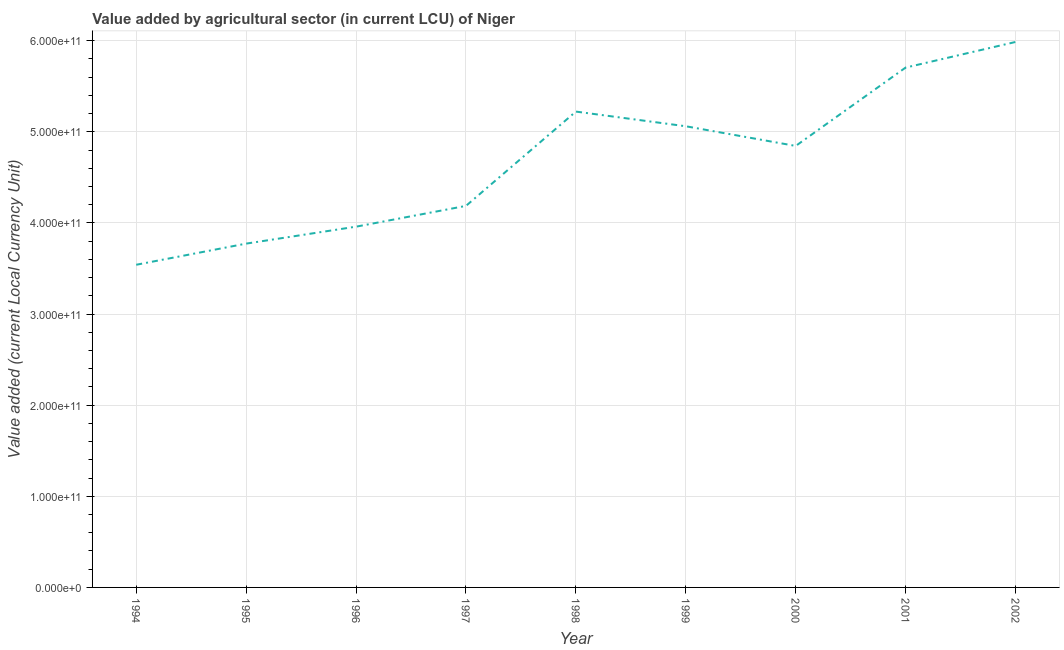What is the value added by agriculture sector in 1998?
Make the answer very short. 5.22e+11. Across all years, what is the maximum value added by agriculture sector?
Give a very brief answer. 5.99e+11. Across all years, what is the minimum value added by agriculture sector?
Ensure brevity in your answer.  3.54e+11. In which year was the value added by agriculture sector maximum?
Provide a short and direct response. 2002. What is the sum of the value added by agriculture sector?
Offer a very short reply. 4.23e+12. What is the difference between the value added by agriculture sector in 1997 and 1999?
Provide a succinct answer. -8.74e+1. What is the average value added by agriculture sector per year?
Make the answer very short. 4.70e+11. What is the median value added by agriculture sector?
Offer a terse response. 4.84e+11. In how many years, is the value added by agriculture sector greater than 220000000000 LCU?
Give a very brief answer. 9. What is the ratio of the value added by agriculture sector in 1998 to that in 1999?
Offer a terse response. 1.03. Is the difference between the value added by agriculture sector in 1998 and 2002 greater than the difference between any two years?
Your answer should be very brief. No. What is the difference between the highest and the second highest value added by agriculture sector?
Provide a short and direct response. 2.81e+1. What is the difference between the highest and the lowest value added by agriculture sector?
Your answer should be very brief. 2.45e+11. In how many years, is the value added by agriculture sector greater than the average value added by agriculture sector taken over all years?
Provide a succinct answer. 5. Does the value added by agriculture sector monotonically increase over the years?
Provide a short and direct response. No. How many lines are there?
Provide a succinct answer. 1. What is the difference between two consecutive major ticks on the Y-axis?
Provide a short and direct response. 1.00e+11. Does the graph contain any zero values?
Provide a short and direct response. No. What is the title of the graph?
Provide a succinct answer. Value added by agricultural sector (in current LCU) of Niger. What is the label or title of the Y-axis?
Your answer should be very brief. Value added (current Local Currency Unit). What is the Value added (current Local Currency Unit) of 1994?
Keep it short and to the point. 3.54e+11. What is the Value added (current Local Currency Unit) in 1995?
Offer a terse response. 3.77e+11. What is the Value added (current Local Currency Unit) of 1996?
Keep it short and to the point. 3.96e+11. What is the Value added (current Local Currency Unit) in 1997?
Provide a succinct answer. 4.19e+11. What is the Value added (current Local Currency Unit) of 1998?
Give a very brief answer. 5.22e+11. What is the Value added (current Local Currency Unit) in 1999?
Make the answer very short. 5.06e+11. What is the Value added (current Local Currency Unit) of 2000?
Your answer should be very brief. 4.84e+11. What is the Value added (current Local Currency Unit) in 2001?
Ensure brevity in your answer.  5.70e+11. What is the Value added (current Local Currency Unit) of 2002?
Your response must be concise. 5.99e+11. What is the difference between the Value added (current Local Currency Unit) in 1994 and 1995?
Offer a terse response. -2.32e+1. What is the difference between the Value added (current Local Currency Unit) in 1994 and 1996?
Ensure brevity in your answer.  -4.18e+1. What is the difference between the Value added (current Local Currency Unit) in 1994 and 1997?
Your answer should be compact. -6.46e+1. What is the difference between the Value added (current Local Currency Unit) in 1994 and 1998?
Give a very brief answer. -1.68e+11. What is the difference between the Value added (current Local Currency Unit) in 1994 and 1999?
Offer a very short reply. -1.52e+11. What is the difference between the Value added (current Local Currency Unit) in 1994 and 2000?
Provide a short and direct response. -1.30e+11. What is the difference between the Value added (current Local Currency Unit) in 1994 and 2001?
Make the answer very short. -2.16e+11. What is the difference between the Value added (current Local Currency Unit) in 1994 and 2002?
Provide a short and direct response. -2.45e+11. What is the difference between the Value added (current Local Currency Unit) in 1995 and 1996?
Give a very brief answer. -1.86e+1. What is the difference between the Value added (current Local Currency Unit) in 1995 and 1997?
Your response must be concise. -4.14e+1. What is the difference between the Value added (current Local Currency Unit) in 1995 and 1998?
Your response must be concise. -1.45e+11. What is the difference between the Value added (current Local Currency Unit) in 1995 and 1999?
Offer a very short reply. -1.29e+11. What is the difference between the Value added (current Local Currency Unit) in 1995 and 2000?
Offer a terse response. -1.07e+11. What is the difference between the Value added (current Local Currency Unit) in 1995 and 2001?
Make the answer very short. -1.93e+11. What is the difference between the Value added (current Local Currency Unit) in 1995 and 2002?
Your answer should be compact. -2.21e+11. What is the difference between the Value added (current Local Currency Unit) in 1996 and 1997?
Make the answer very short. -2.28e+1. What is the difference between the Value added (current Local Currency Unit) in 1996 and 1998?
Your answer should be very brief. -1.26e+11. What is the difference between the Value added (current Local Currency Unit) in 1996 and 1999?
Provide a short and direct response. -1.10e+11. What is the difference between the Value added (current Local Currency Unit) in 1996 and 2000?
Give a very brief answer. -8.86e+1. What is the difference between the Value added (current Local Currency Unit) in 1996 and 2001?
Provide a succinct answer. -1.75e+11. What is the difference between the Value added (current Local Currency Unit) in 1996 and 2002?
Make the answer very short. -2.03e+11. What is the difference between the Value added (current Local Currency Unit) in 1997 and 1998?
Offer a very short reply. -1.03e+11. What is the difference between the Value added (current Local Currency Unit) in 1997 and 1999?
Offer a terse response. -8.74e+1. What is the difference between the Value added (current Local Currency Unit) in 1997 and 2000?
Offer a terse response. -6.58e+1. What is the difference between the Value added (current Local Currency Unit) in 1997 and 2001?
Ensure brevity in your answer.  -1.52e+11. What is the difference between the Value added (current Local Currency Unit) in 1997 and 2002?
Make the answer very short. -1.80e+11. What is the difference between the Value added (current Local Currency Unit) in 1998 and 1999?
Provide a short and direct response. 1.61e+1. What is the difference between the Value added (current Local Currency Unit) in 1998 and 2000?
Provide a succinct answer. 3.77e+1. What is the difference between the Value added (current Local Currency Unit) in 1998 and 2001?
Offer a terse response. -4.83e+1. What is the difference between the Value added (current Local Currency Unit) in 1998 and 2002?
Provide a succinct answer. -7.64e+1. What is the difference between the Value added (current Local Currency Unit) in 1999 and 2000?
Ensure brevity in your answer.  2.16e+1. What is the difference between the Value added (current Local Currency Unit) in 1999 and 2001?
Provide a short and direct response. -6.44e+1. What is the difference between the Value added (current Local Currency Unit) in 1999 and 2002?
Ensure brevity in your answer.  -9.25e+1. What is the difference between the Value added (current Local Currency Unit) in 2000 and 2001?
Provide a succinct answer. -8.60e+1. What is the difference between the Value added (current Local Currency Unit) in 2000 and 2002?
Your answer should be compact. -1.14e+11. What is the difference between the Value added (current Local Currency Unit) in 2001 and 2002?
Your answer should be compact. -2.81e+1. What is the ratio of the Value added (current Local Currency Unit) in 1994 to that in 1995?
Your answer should be very brief. 0.94. What is the ratio of the Value added (current Local Currency Unit) in 1994 to that in 1996?
Provide a short and direct response. 0.89. What is the ratio of the Value added (current Local Currency Unit) in 1994 to that in 1997?
Offer a very short reply. 0.85. What is the ratio of the Value added (current Local Currency Unit) in 1994 to that in 1998?
Make the answer very short. 0.68. What is the ratio of the Value added (current Local Currency Unit) in 1994 to that in 1999?
Offer a terse response. 0.7. What is the ratio of the Value added (current Local Currency Unit) in 1994 to that in 2000?
Offer a very short reply. 0.73. What is the ratio of the Value added (current Local Currency Unit) in 1994 to that in 2001?
Make the answer very short. 0.62. What is the ratio of the Value added (current Local Currency Unit) in 1994 to that in 2002?
Give a very brief answer. 0.59. What is the ratio of the Value added (current Local Currency Unit) in 1995 to that in 1996?
Provide a succinct answer. 0.95. What is the ratio of the Value added (current Local Currency Unit) in 1995 to that in 1997?
Keep it short and to the point. 0.9. What is the ratio of the Value added (current Local Currency Unit) in 1995 to that in 1998?
Keep it short and to the point. 0.72. What is the ratio of the Value added (current Local Currency Unit) in 1995 to that in 1999?
Your answer should be compact. 0.75. What is the ratio of the Value added (current Local Currency Unit) in 1995 to that in 2000?
Your response must be concise. 0.78. What is the ratio of the Value added (current Local Currency Unit) in 1995 to that in 2001?
Offer a very short reply. 0.66. What is the ratio of the Value added (current Local Currency Unit) in 1995 to that in 2002?
Make the answer very short. 0.63. What is the ratio of the Value added (current Local Currency Unit) in 1996 to that in 1997?
Offer a terse response. 0.95. What is the ratio of the Value added (current Local Currency Unit) in 1996 to that in 1998?
Offer a very short reply. 0.76. What is the ratio of the Value added (current Local Currency Unit) in 1996 to that in 1999?
Provide a short and direct response. 0.78. What is the ratio of the Value added (current Local Currency Unit) in 1996 to that in 2000?
Offer a very short reply. 0.82. What is the ratio of the Value added (current Local Currency Unit) in 1996 to that in 2001?
Provide a succinct answer. 0.69. What is the ratio of the Value added (current Local Currency Unit) in 1996 to that in 2002?
Your answer should be very brief. 0.66. What is the ratio of the Value added (current Local Currency Unit) in 1997 to that in 1998?
Offer a very short reply. 0.8. What is the ratio of the Value added (current Local Currency Unit) in 1997 to that in 1999?
Your answer should be compact. 0.83. What is the ratio of the Value added (current Local Currency Unit) in 1997 to that in 2000?
Your answer should be very brief. 0.86. What is the ratio of the Value added (current Local Currency Unit) in 1997 to that in 2001?
Ensure brevity in your answer.  0.73. What is the ratio of the Value added (current Local Currency Unit) in 1997 to that in 2002?
Keep it short and to the point. 0.7. What is the ratio of the Value added (current Local Currency Unit) in 1998 to that in 1999?
Offer a terse response. 1.03. What is the ratio of the Value added (current Local Currency Unit) in 1998 to that in 2000?
Make the answer very short. 1.08. What is the ratio of the Value added (current Local Currency Unit) in 1998 to that in 2001?
Provide a succinct answer. 0.92. What is the ratio of the Value added (current Local Currency Unit) in 1998 to that in 2002?
Give a very brief answer. 0.87. What is the ratio of the Value added (current Local Currency Unit) in 1999 to that in 2000?
Offer a very short reply. 1.04. What is the ratio of the Value added (current Local Currency Unit) in 1999 to that in 2001?
Your answer should be compact. 0.89. What is the ratio of the Value added (current Local Currency Unit) in 1999 to that in 2002?
Provide a short and direct response. 0.84. What is the ratio of the Value added (current Local Currency Unit) in 2000 to that in 2001?
Your response must be concise. 0.85. What is the ratio of the Value added (current Local Currency Unit) in 2000 to that in 2002?
Keep it short and to the point. 0.81. What is the ratio of the Value added (current Local Currency Unit) in 2001 to that in 2002?
Your answer should be compact. 0.95. 